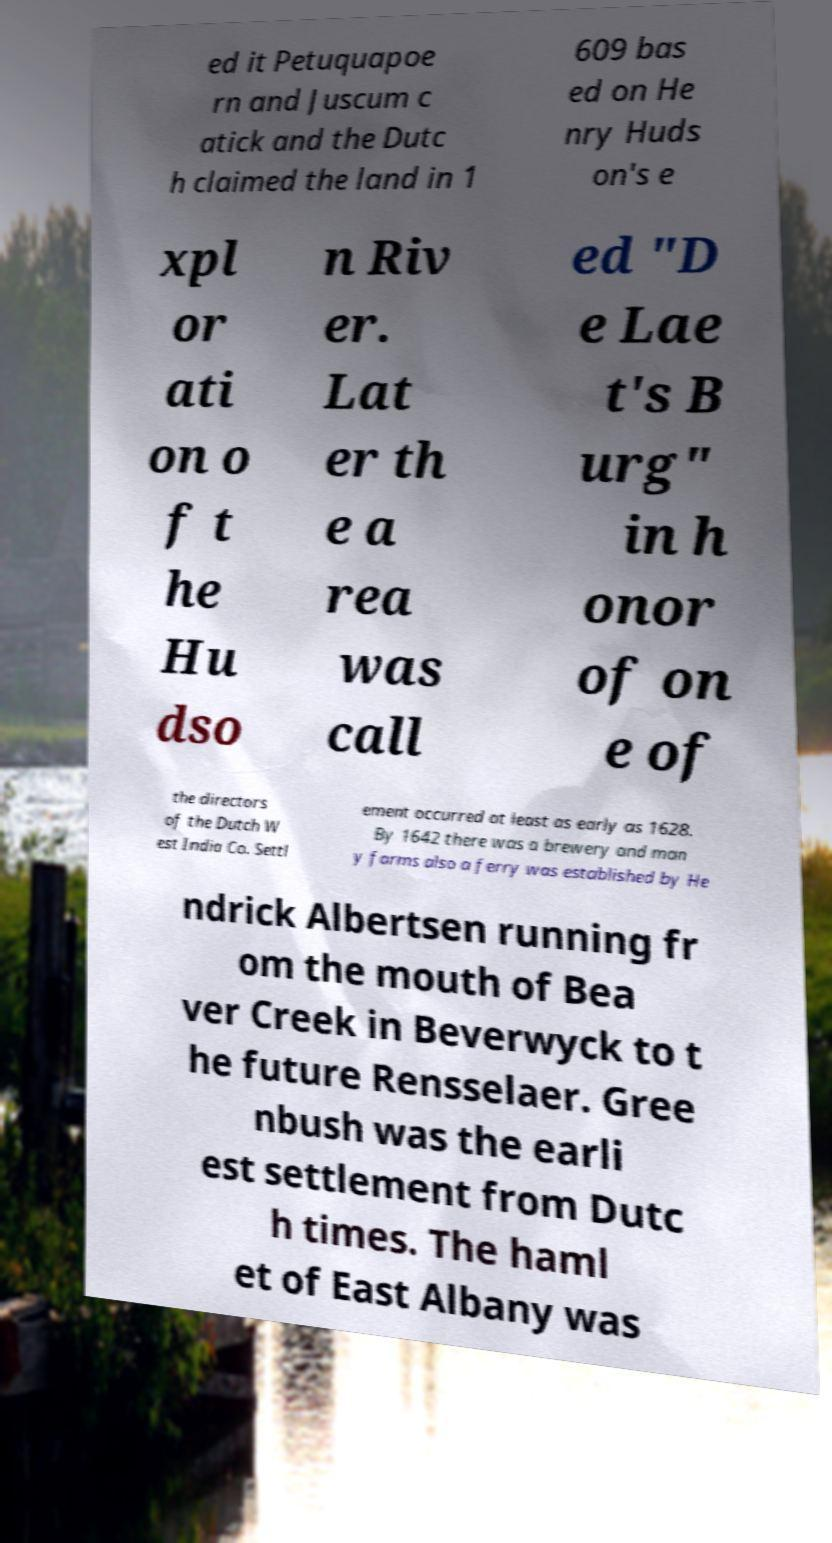Could you assist in decoding the text presented in this image and type it out clearly? ed it Petuquapoe rn and Juscum c atick and the Dutc h claimed the land in 1 609 bas ed on He nry Huds on's e xpl or ati on o f t he Hu dso n Riv er. Lat er th e a rea was call ed "D e Lae t's B urg" in h onor of on e of the directors of the Dutch W est India Co. Settl ement occurred at least as early as 1628. By 1642 there was a brewery and man y farms also a ferry was established by He ndrick Albertsen running fr om the mouth of Bea ver Creek in Beverwyck to t he future Rensselaer. Gree nbush was the earli est settlement from Dutc h times. The haml et of East Albany was 